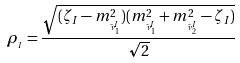Convert formula to latex. <formula><loc_0><loc_0><loc_500><loc_500>\rho _ { _ { I } } = \frac { \sqrt { ( \zeta _ { I } - m _ { _ { \tilde { \nu } _ { 1 } ^ { I } } } ^ { 2 } ) ( m _ { _ { \tilde { \nu } _ { 1 } ^ { I } } } ^ { 2 } + m _ { _ { \tilde { \nu } _ { 2 } ^ { I } } } ^ { 2 } - \zeta _ { I } ) } } { \sqrt { 2 } }</formula> 